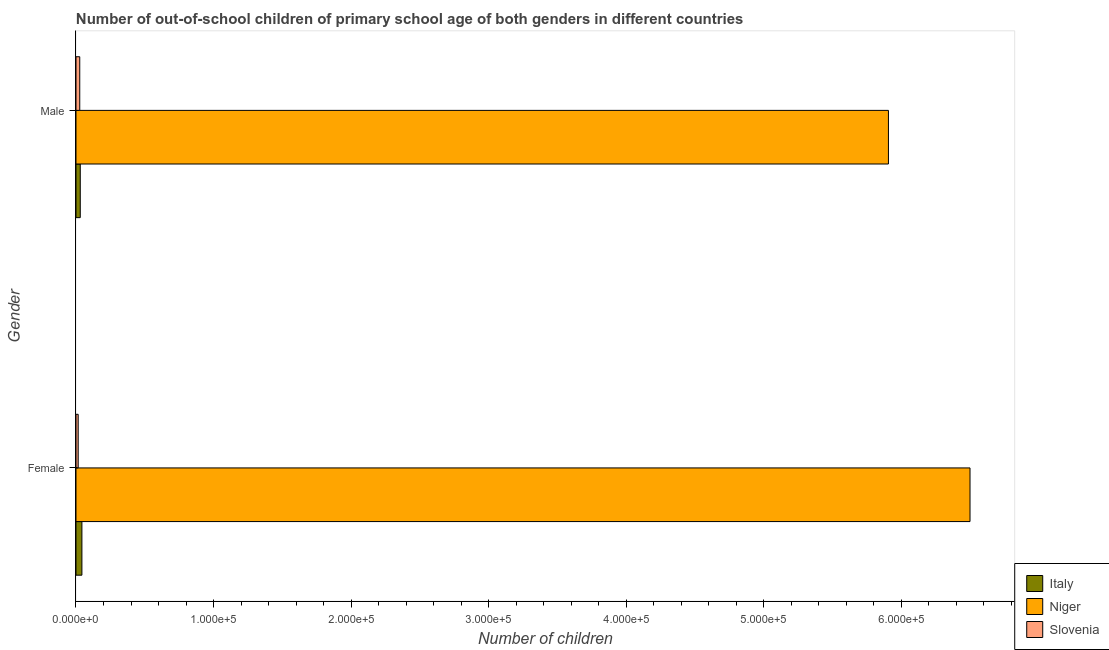Are the number of bars per tick equal to the number of legend labels?
Your response must be concise. Yes. How many bars are there on the 2nd tick from the top?
Offer a terse response. 3. How many bars are there on the 2nd tick from the bottom?
Your answer should be compact. 3. What is the label of the 1st group of bars from the top?
Your response must be concise. Male. What is the number of female out-of-school students in Slovenia?
Your answer should be compact. 1602. Across all countries, what is the maximum number of male out-of-school students?
Offer a terse response. 5.91e+05. Across all countries, what is the minimum number of male out-of-school students?
Ensure brevity in your answer.  2737. In which country was the number of male out-of-school students maximum?
Offer a terse response. Niger. In which country was the number of female out-of-school students minimum?
Provide a succinct answer. Slovenia. What is the total number of male out-of-school students in the graph?
Your response must be concise. 5.96e+05. What is the difference between the number of female out-of-school students in Italy and that in Slovenia?
Your answer should be very brief. 2699. What is the difference between the number of female out-of-school students in Niger and the number of male out-of-school students in Slovenia?
Your response must be concise. 6.47e+05. What is the average number of female out-of-school students per country?
Give a very brief answer. 2.19e+05. What is the difference between the number of female out-of-school students and number of male out-of-school students in Slovenia?
Keep it short and to the point. -1135. What is the ratio of the number of female out-of-school students in Italy to that in Niger?
Offer a terse response. 0.01. Is the number of female out-of-school students in Italy less than that in Niger?
Make the answer very short. Yes. What does the 1st bar from the top in Female represents?
Offer a very short reply. Slovenia. What does the 3rd bar from the bottom in Male represents?
Provide a short and direct response. Slovenia. Are all the bars in the graph horizontal?
Provide a succinct answer. Yes. How many countries are there in the graph?
Give a very brief answer. 3. What is the title of the graph?
Your response must be concise. Number of out-of-school children of primary school age of both genders in different countries. What is the label or title of the X-axis?
Your response must be concise. Number of children. What is the Number of children in Italy in Female?
Give a very brief answer. 4301. What is the Number of children in Niger in Female?
Provide a succinct answer. 6.50e+05. What is the Number of children of Slovenia in Female?
Give a very brief answer. 1602. What is the Number of children in Italy in Male?
Ensure brevity in your answer.  3105. What is the Number of children of Niger in Male?
Ensure brevity in your answer.  5.91e+05. What is the Number of children in Slovenia in Male?
Offer a terse response. 2737. Across all Gender, what is the maximum Number of children in Italy?
Provide a short and direct response. 4301. Across all Gender, what is the maximum Number of children of Niger?
Your response must be concise. 6.50e+05. Across all Gender, what is the maximum Number of children in Slovenia?
Your answer should be compact. 2737. Across all Gender, what is the minimum Number of children in Italy?
Give a very brief answer. 3105. Across all Gender, what is the minimum Number of children in Niger?
Offer a very short reply. 5.91e+05. Across all Gender, what is the minimum Number of children in Slovenia?
Provide a succinct answer. 1602. What is the total Number of children in Italy in the graph?
Your answer should be compact. 7406. What is the total Number of children in Niger in the graph?
Offer a terse response. 1.24e+06. What is the total Number of children of Slovenia in the graph?
Keep it short and to the point. 4339. What is the difference between the Number of children of Italy in Female and that in Male?
Keep it short and to the point. 1196. What is the difference between the Number of children of Niger in Female and that in Male?
Provide a succinct answer. 5.93e+04. What is the difference between the Number of children in Slovenia in Female and that in Male?
Ensure brevity in your answer.  -1135. What is the difference between the Number of children in Italy in Female and the Number of children in Niger in Male?
Offer a terse response. -5.86e+05. What is the difference between the Number of children of Italy in Female and the Number of children of Slovenia in Male?
Your answer should be very brief. 1564. What is the difference between the Number of children of Niger in Female and the Number of children of Slovenia in Male?
Give a very brief answer. 6.47e+05. What is the average Number of children of Italy per Gender?
Provide a short and direct response. 3703. What is the average Number of children of Niger per Gender?
Your response must be concise. 6.20e+05. What is the average Number of children of Slovenia per Gender?
Provide a succinct answer. 2169.5. What is the difference between the Number of children in Italy and Number of children in Niger in Female?
Provide a short and direct response. -6.46e+05. What is the difference between the Number of children of Italy and Number of children of Slovenia in Female?
Make the answer very short. 2699. What is the difference between the Number of children of Niger and Number of children of Slovenia in Female?
Your answer should be very brief. 6.48e+05. What is the difference between the Number of children in Italy and Number of children in Niger in Male?
Your response must be concise. -5.88e+05. What is the difference between the Number of children of Italy and Number of children of Slovenia in Male?
Your response must be concise. 368. What is the difference between the Number of children in Niger and Number of children in Slovenia in Male?
Offer a terse response. 5.88e+05. What is the ratio of the Number of children in Italy in Female to that in Male?
Your answer should be very brief. 1.39. What is the ratio of the Number of children in Niger in Female to that in Male?
Offer a very short reply. 1.1. What is the ratio of the Number of children in Slovenia in Female to that in Male?
Make the answer very short. 0.59. What is the difference between the highest and the second highest Number of children in Italy?
Provide a short and direct response. 1196. What is the difference between the highest and the second highest Number of children of Niger?
Offer a terse response. 5.93e+04. What is the difference between the highest and the second highest Number of children of Slovenia?
Make the answer very short. 1135. What is the difference between the highest and the lowest Number of children of Italy?
Your response must be concise. 1196. What is the difference between the highest and the lowest Number of children in Niger?
Your answer should be very brief. 5.93e+04. What is the difference between the highest and the lowest Number of children of Slovenia?
Provide a short and direct response. 1135. 